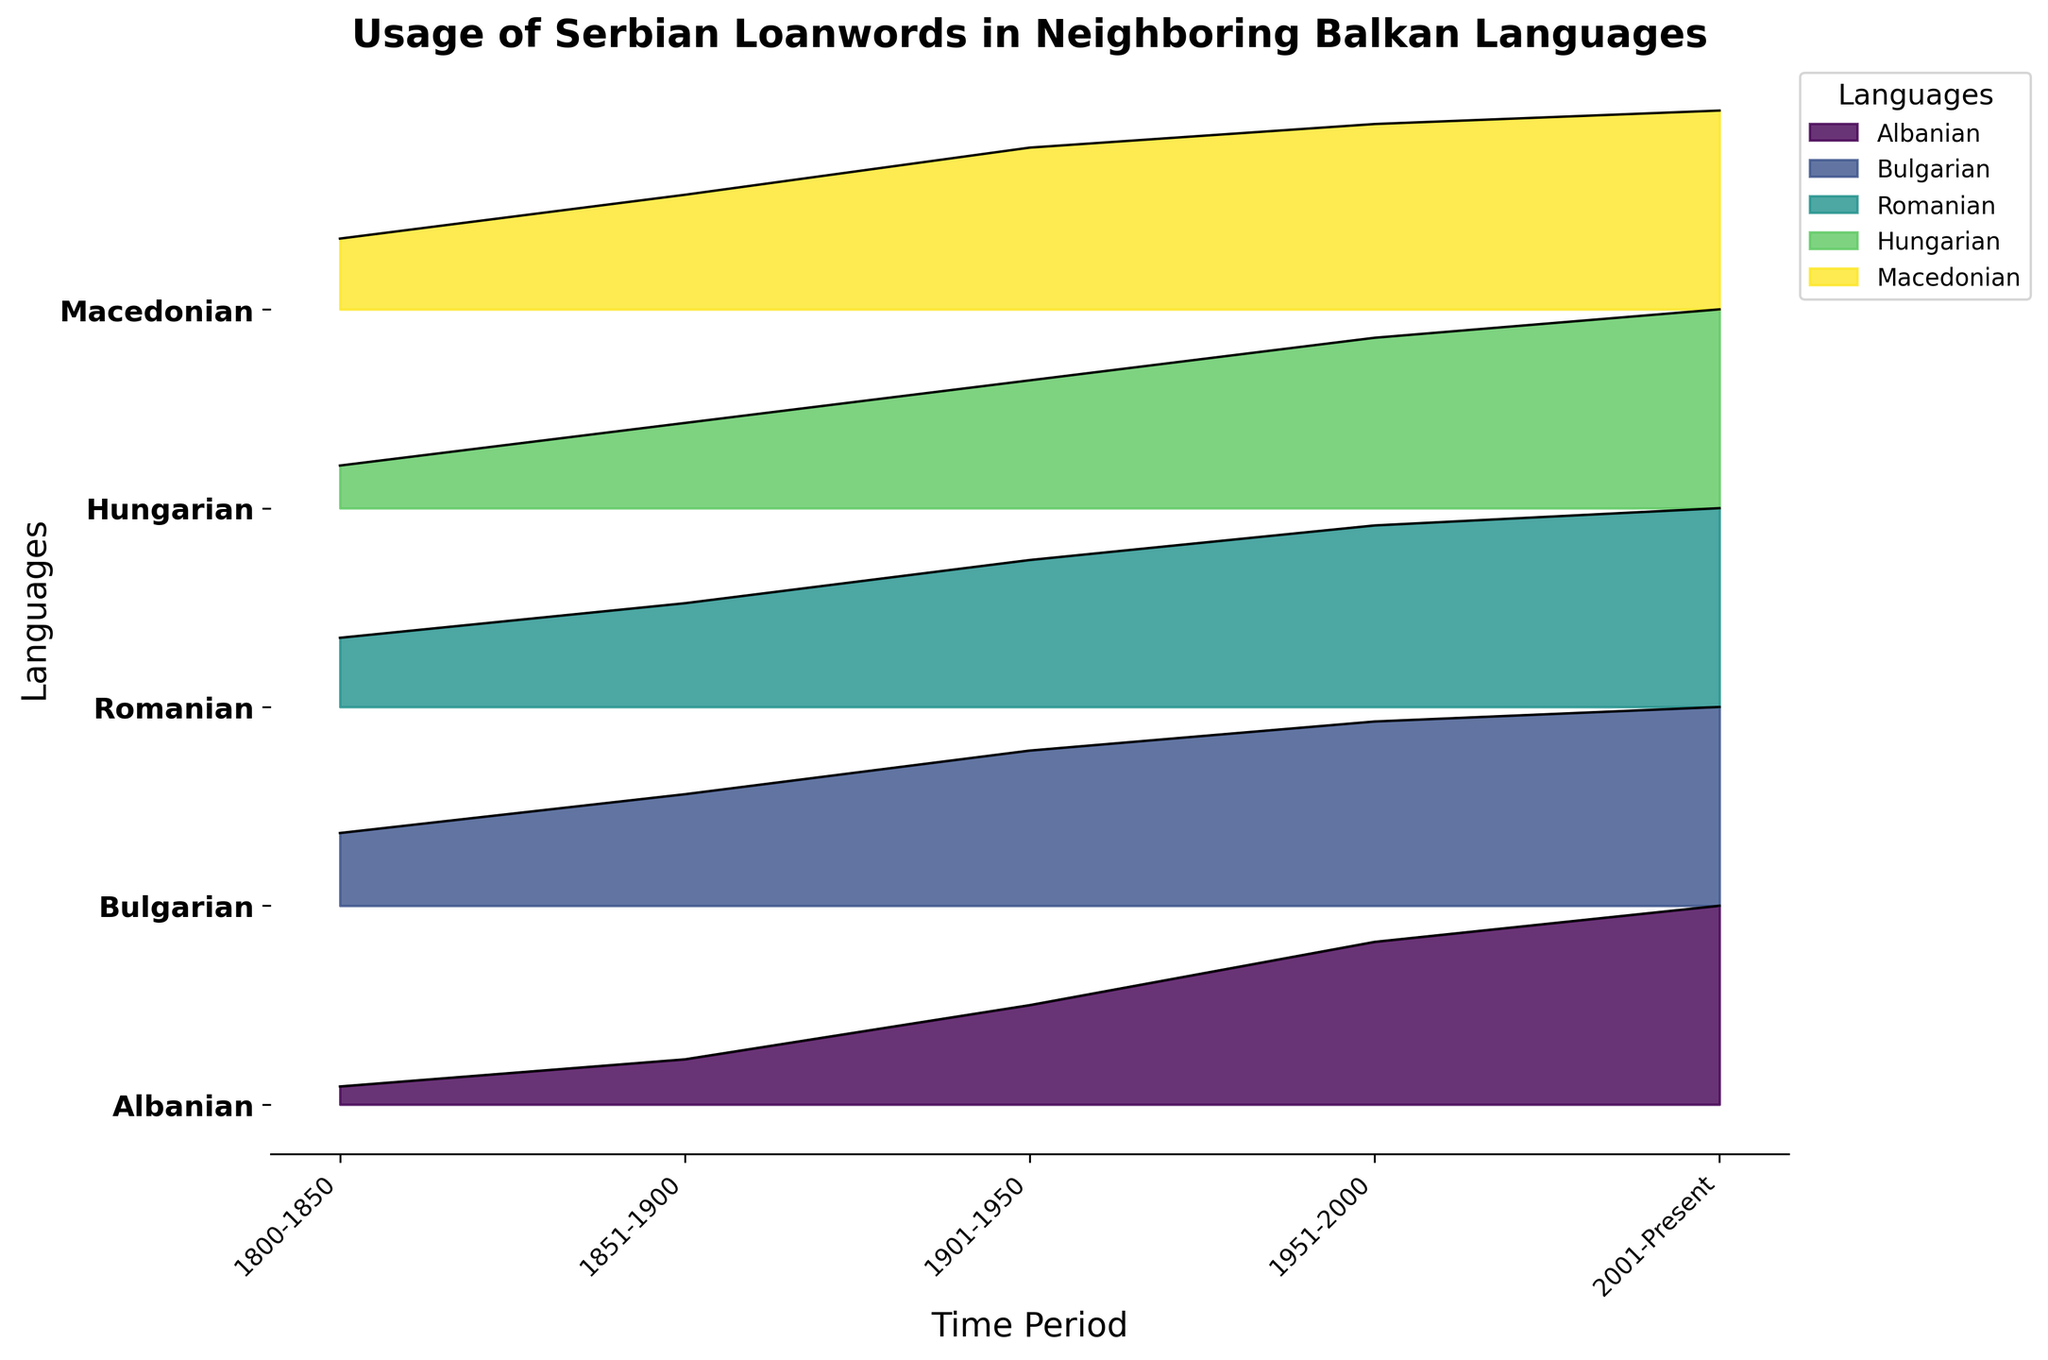What is the title of the figure? The title of the figure is displayed at the top of the plot and provides a concise description of what the figure is about.
Answer: Usage of Serbian Loanwords in Neighboring Balkan Languages Which language has the greatest increase in usage of Serbian loanwords from 1800-1850 to 2001-Present? To find the language with the greatest increase, look at the loanword usage values for 1800-1850 and 2001-Present for all languages, and compute their differences. Bulgarian increases from 1.5 to 4.1 (2.6), while Macedonian increases from 2.1 to 5.9 (3.8), showing the greatest increase.
Answer: Macedonian What is the trend in the usage of Serbian loanwords in Hungarian over time? Observe the Hungarian line across the time periods and note the general direction of its change. Starting from 0.3 and increasing steadily to 1.4, loanword usage in Hungarian shows a consistent rising trend.
Answer: Increasing Which language shows the least variability in usage of Serbian loanwords over the time periods? Compare the range of values (difference between the maximum and the minimum) for each language. Hungarian's values range from 0.3 to 1.4, which is 1.1, the smallest range among the languages.
Answer: Hungarian How does the usage of Serbian loanwords in Romanian compare to Macedonian in the period 1951-2000? Look at the values for 1951-2000 for Romanian and Macedonian. Romanian has 2.1, whereas Macedonian has 5.5 during this period; Macedonian usage is higher.
Answer: Macedonian has higher usage What is the color used to represent Romanian in the plot? Each language is represented by a different color in the plot. The key for identifying which color corresponds to Romanian is located in the legend.
Answer: (Specify the exact color name if visible, like 'green' or 'blue', as observed in the legend.) Which time period shows the highest overall usage of Serbian loanwords across all languages? Sum the loanword usage for all languages within each time period and identify the period with the highest total. The 2001-Present period summing up (2.2 + 4.1 + 2.3 + 1.4 + 5.9) equals 15.9, the highest sum.
Answer: 2001-Present In the time period 1901-1950, which language had the second-highest usage of Serbian loanwords? Look at the values for the period 1901-1950 and rank the languages by loanword usage. Macedonian has the highest usage at 4.8, followed by Bulgarian at 3.2.
Answer: Bulgarian What can be said about the comparative trend of loanword usage in Albanian and Romanian over time? Observe the patterns and slopes for Albanian and Romanian lines across the time periods. Both languages show an increasing trend, but the increase in Romanian is more significant than in Albanian.
Answer: Both increase, Romanian increases more Which language had the highest usage of Serbian loanwords during 1851-1900? Identify and compare the usage values for each language in the 1851-1900 period. The highest value is for Macedonian at 3.4.
Answer: Macedonian 